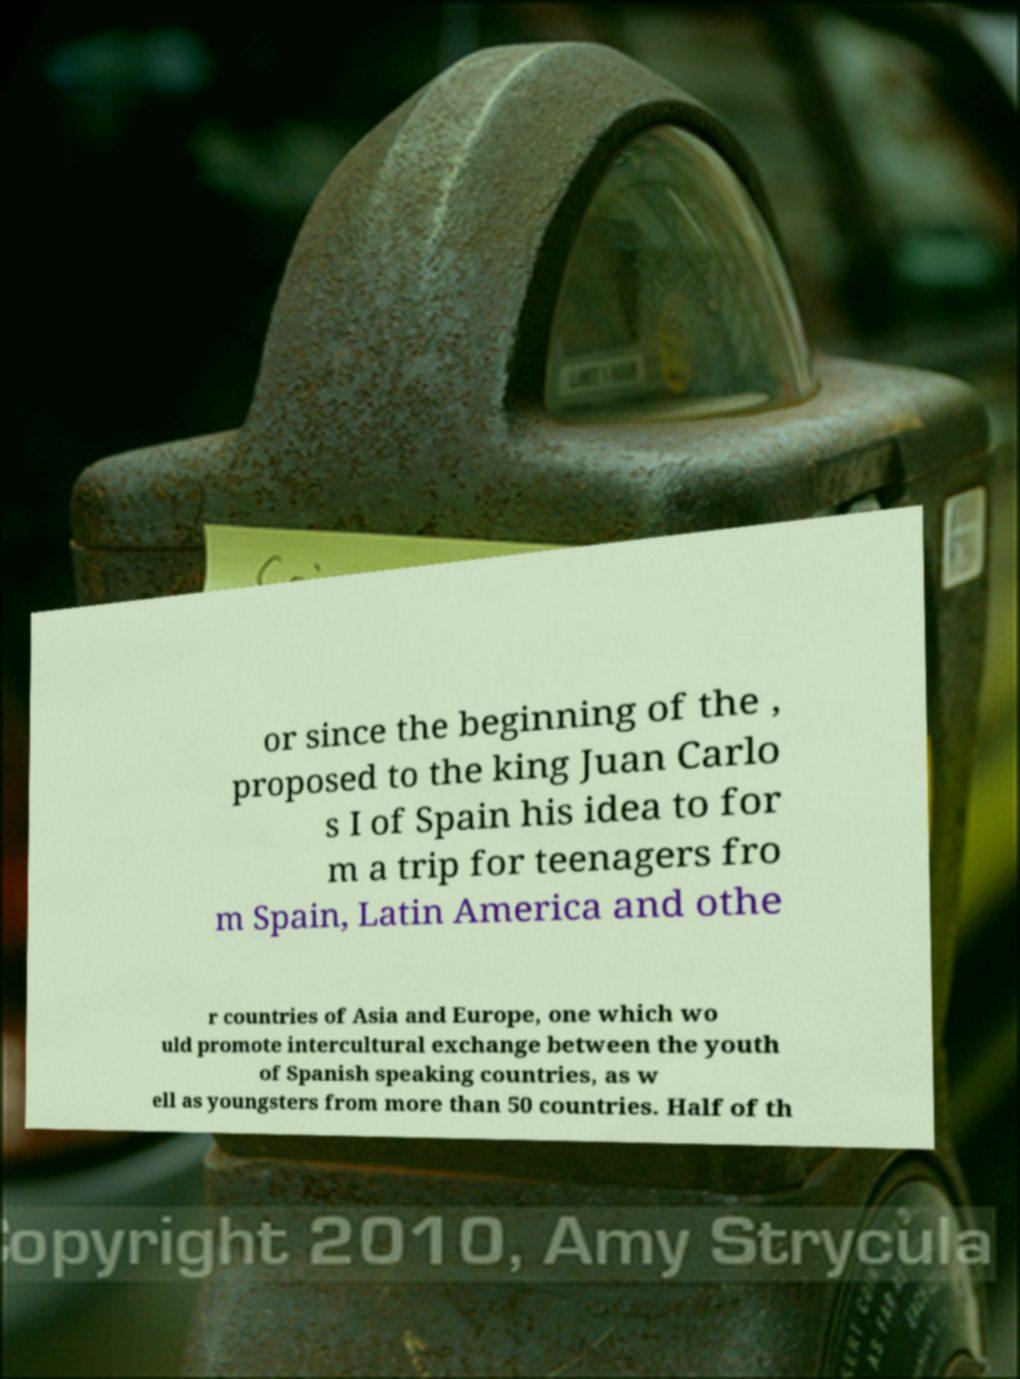Could you extract and type out the text from this image? or since the beginning of the , proposed to the king Juan Carlo s I of Spain his idea to for m a trip for teenagers fro m Spain, Latin America and othe r countries of Asia and Europe, one which wo uld promote intercultural exchange between the youth of Spanish speaking countries, as w ell as youngsters from more than 50 countries. Half of th 